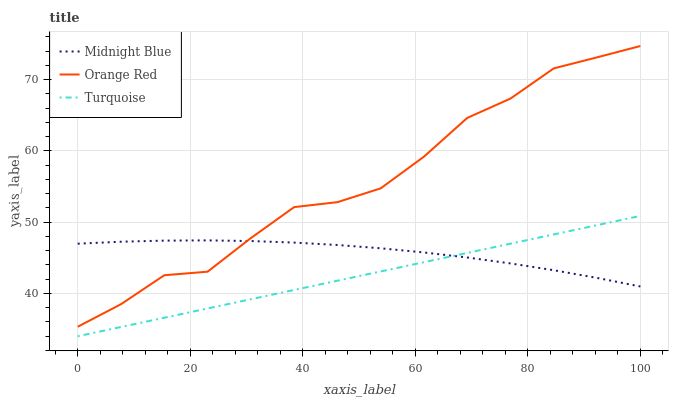Does Turquoise have the minimum area under the curve?
Answer yes or no. Yes. Does Orange Red have the maximum area under the curve?
Answer yes or no. Yes. Does Midnight Blue have the minimum area under the curve?
Answer yes or no. No. Does Midnight Blue have the maximum area under the curve?
Answer yes or no. No. Is Turquoise the smoothest?
Answer yes or no. Yes. Is Orange Red the roughest?
Answer yes or no. Yes. Is Midnight Blue the smoothest?
Answer yes or no. No. Is Midnight Blue the roughest?
Answer yes or no. No. Does Turquoise have the lowest value?
Answer yes or no. Yes. Does Orange Red have the lowest value?
Answer yes or no. No. Does Orange Red have the highest value?
Answer yes or no. Yes. Does Midnight Blue have the highest value?
Answer yes or no. No. Is Turquoise less than Orange Red?
Answer yes or no. Yes. Is Orange Red greater than Turquoise?
Answer yes or no. Yes. Does Orange Red intersect Midnight Blue?
Answer yes or no. Yes. Is Orange Red less than Midnight Blue?
Answer yes or no. No. Is Orange Red greater than Midnight Blue?
Answer yes or no. No. Does Turquoise intersect Orange Red?
Answer yes or no. No. 